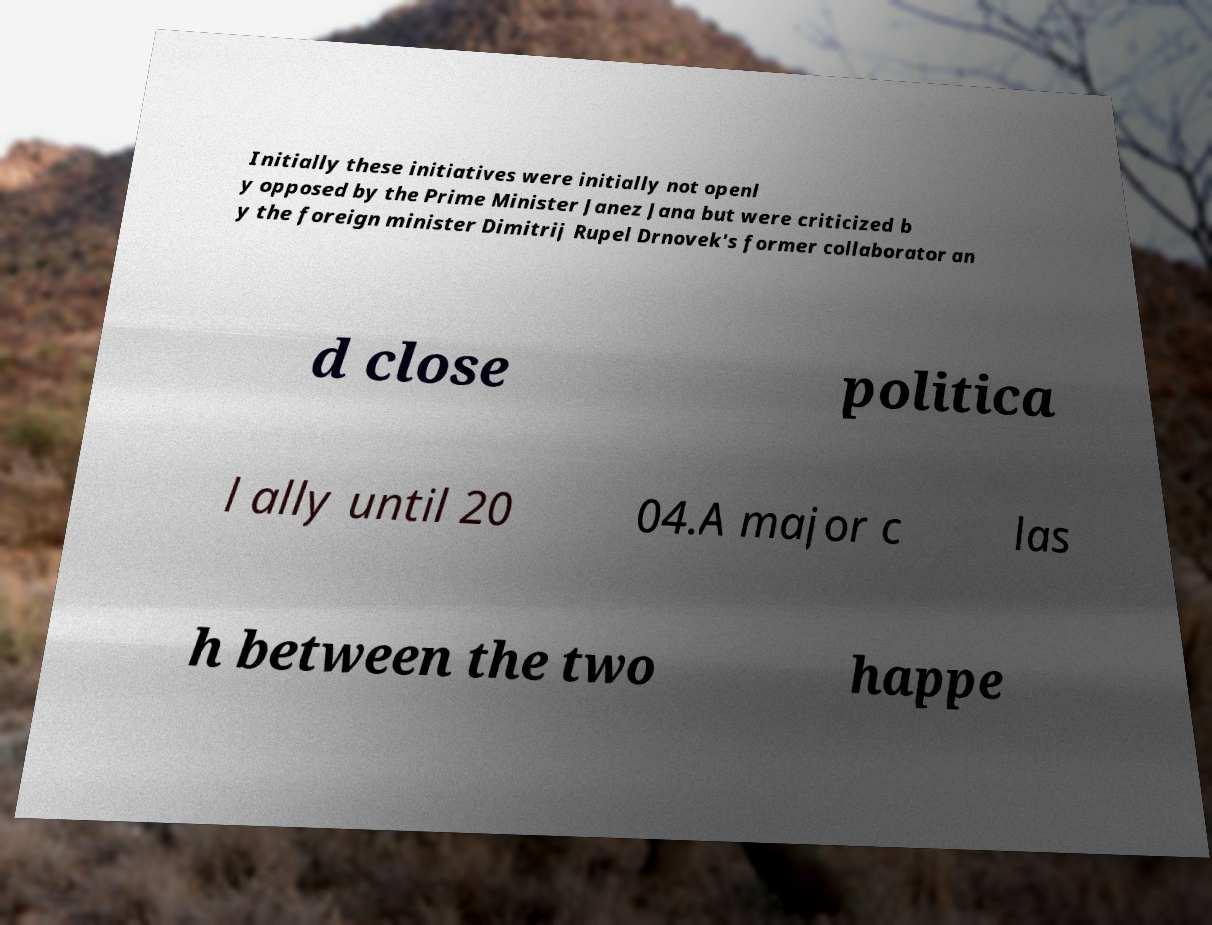Please identify and transcribe the text found in this image. Initially these initiatives were initially not openl y opposed by the Prime Minister Janez Jana but were criticized b y the foreign minister Dimitrij Rupel Drnovek's former collaborator an d close politica l ally until 20 04.A major c las h between the two happe 